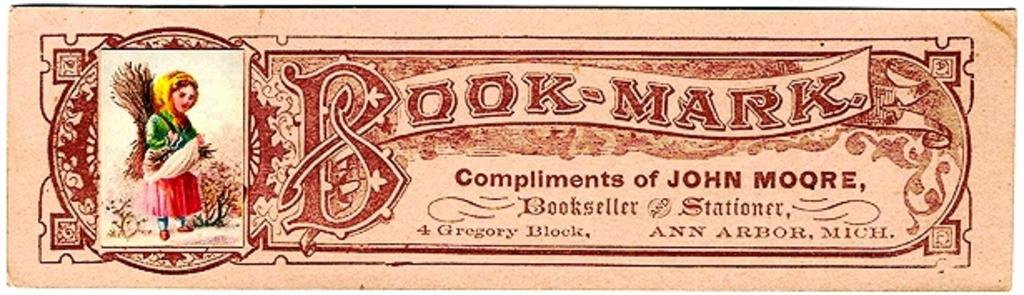What is present on the wall in the image? There is a poster in the image. What can be seen on the poster? The poster has a picture on it. What else is featured on the poster besides the image? There is text on the poster. How many tomatoes are placed on the nut in the image? There are no tomatoes or nuts present in the image; it only features a poster with a picture and text. 